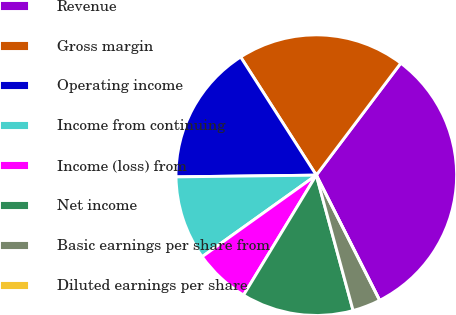Convert chart to OTSL. <chart><loc_0><loc_0><loc_500><loc_500><pie_chart><fcel>Revenue<fcel>Gross margin<fcel>Operating income<fcel>Income from continuing<fcel>Income (loss) from<fcel>Net income<fcel>Basic earnings per share from<fcel>Diluted earnings per share<nl><fcel>32.26%<fcel>19.35%<fcel>16.13%<fcel>9.68%<fcel>6.45%<fcel>12.9%<fcel>3.23%<fcel>0.0%<nl></chart> 